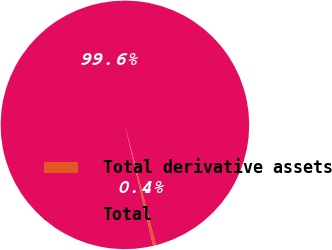<chart> <loc_0><loc_0><loc_500><loc_500><pie_chart><fcel>Total derivative assets<fcel>Total<nl><fcel>0.38%<fcel>99.62%<nl></chart> 